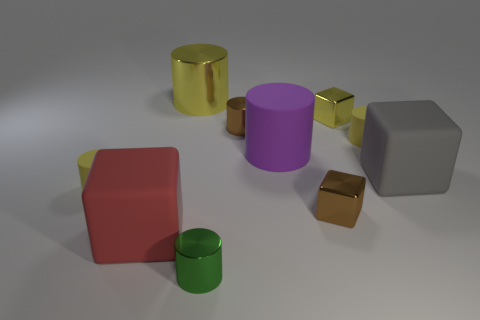Subtract all gray blocks. How many blocks are left? 3 Subtract all gray cubes. How many cubes are left? 3 Subtract all gray cubes. How many purple cylinders are left? 1 Add 7 brown objects. How many brown objects are left? 9 Add 1 big red matte objects. How many big red matte objects exist? 2 Subtract 0 green balls. How many objects are left? 10 Subtract all cylinders. How many objects are left? 4 Subtract 5 cylinders. How many cylinders are left? 1 Subtract all gray cubes. Subtract all green spheres. How many cubes are left? 3 Subtract all gray matte cubes. Subtract all small green metallic cylinders. How many objects are left? 8 